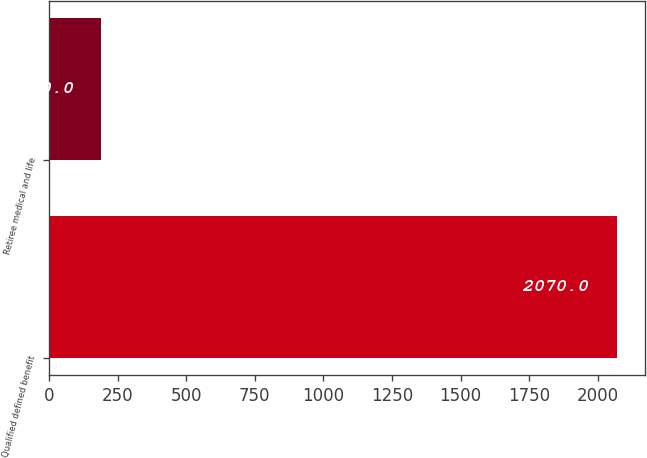<chart> <loc_0><loc_0><loc_500><loc_500><bar_chart><fcel>Qualified defined benefit<fcel>Retiree medical and life<nl><fcel>2070<fcel>190<nl></chart> 